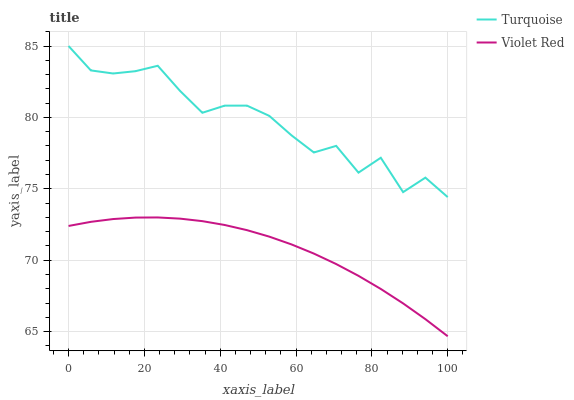Does Violet Red have the minimum area under the curve?
Answer yes or no. Yes. Does Turquoise have the maximum area under the curve?
Answer yes or no. Yes. Does Violet Red have the maximum area under the curve?
Answer yes or no. No. Is Violet Red the smoothest?
Answer yes or no. Yes. Is Turquoise the roughest?
Answer yes or no. Yes. Is Violet Red the roughest?
Answer yes or no. No. Does Violet Red have the lowest value?
Answer yes or no. Yes. Does Turquoise have the highest value?
Answer yes or no. Yes. Does Violet Red have the highest value?
Answer yes or no. No. Is Violet Red less than Turquoise?
Answer yes or no. Yes. Is Turquoise greater than Violet Red?
Answer yes or no. Yes. Does Violet Red intersect Turquoise?
Answer yes or no. No. 